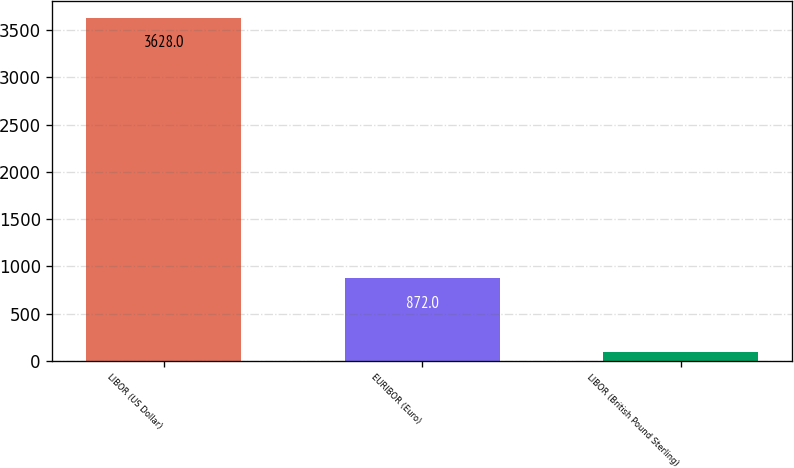<chart> <loc_0><loc_0><loc_500><loc_500><bar_chart><fcel>LIBOR (US Dollar)<fcel>EURIBOR (Euro)<fcel>LIBOR (British Pound Sterling)<nl><fcel>3628<fcel>872<fcel>90<nl></chart> 